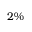Convert formula to latex. <formula><loc_0><loc_0><loc_500><loc_500>2 \%</formula> 